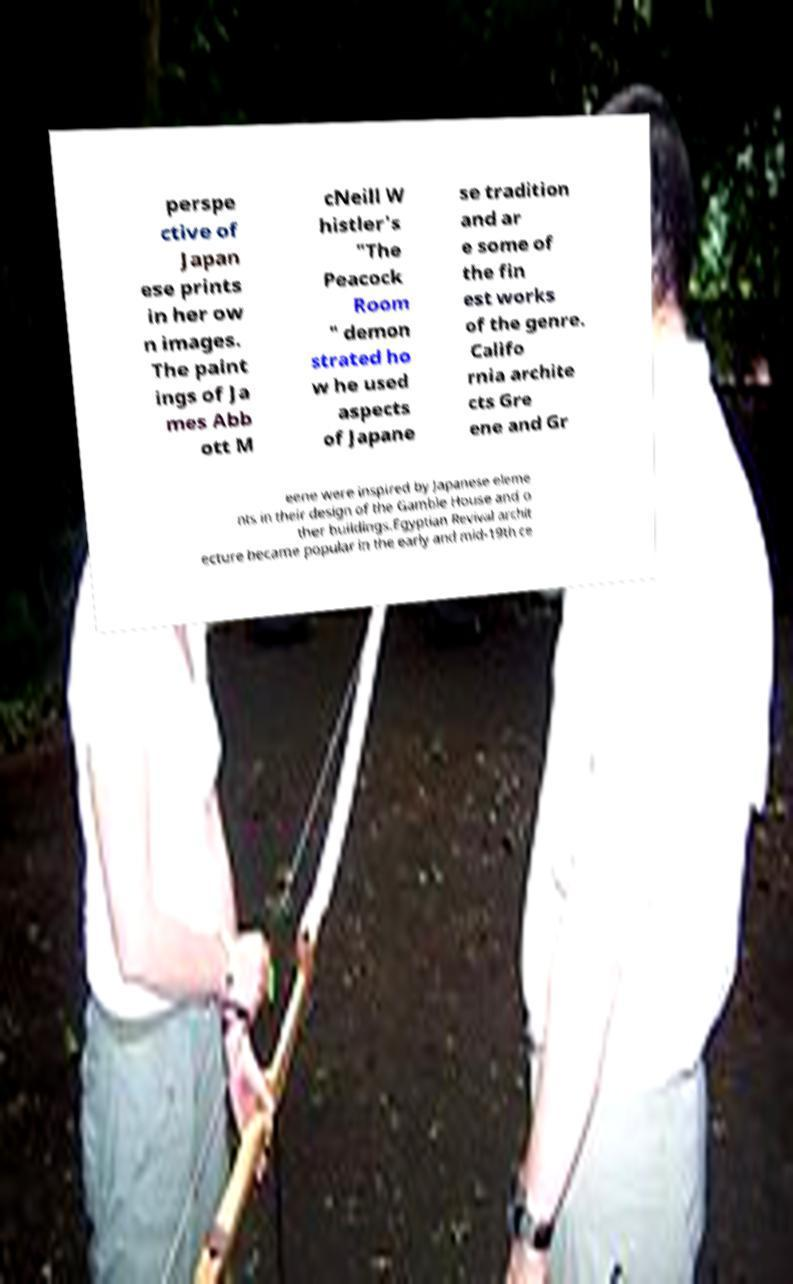Please read and relay the text visible in this image. What does it say? perspe ctive of Japan ese prints in her ow n images. The paint ings of Ja mes Abb ott M cNeill W histler's "The Peacock Room " demon strated ho w he used aspects of Japane se tradition and ar e some of the fin est works of the genre. Califo rnia archite cts Gre ene and Gr eene were inspired by Japanese eleme nts in their design of the Gamble House and o ther buildings.Egyptian Revival archit ecture became popular in the early and mid-19th ce 